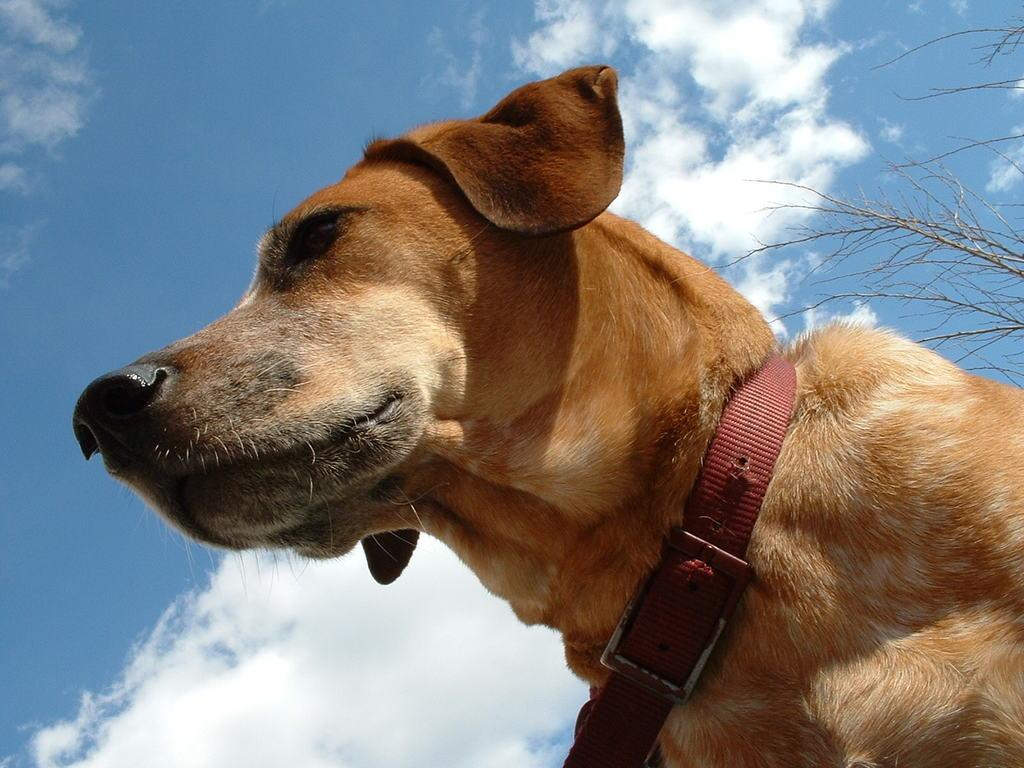What type of animal is in the image? There is a dog in the image. Can you describe the dog's appearance? The dog is brown and white in color. What can be seen in the background of the image? There are dried trees in the background of the image. What is the color of the sky in the image? The sky is blue and white in color. How many ants can be seen crawling on the dog's fur in the image? There are no ants visible in the image; it only features a dog, dried trees, and a blue and white sky. 